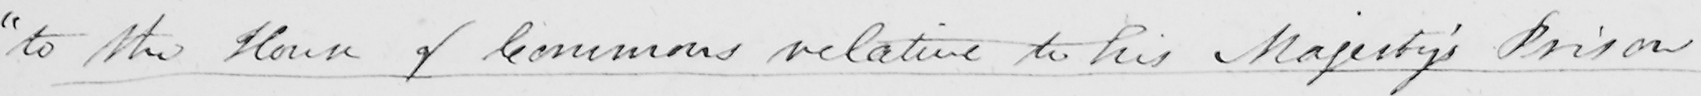What does this handwritten line say? " to the House of Commons relative to his Majesty ' s Prison 